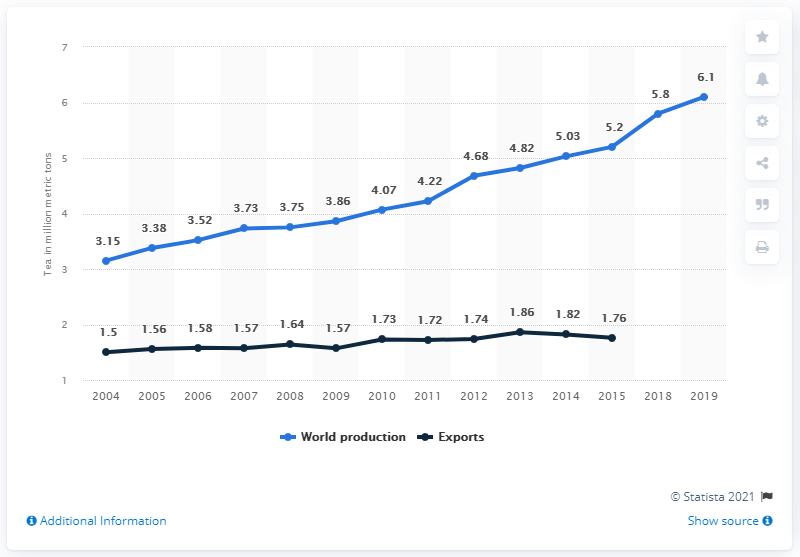Specify some key components in this picture. According to estimates, global tea production in 2019 was approximately 6.1 billion kilograms. 